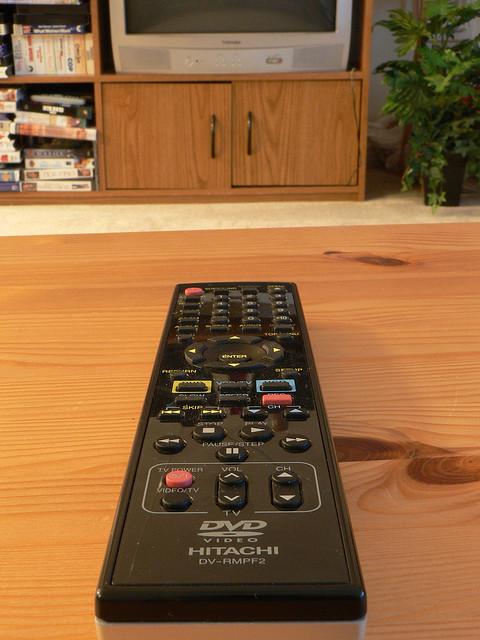What is this remote used for?
Write a very short answer. Tv. What electronic device can be seen?
Concise answer only. Tv. What is on top of the table?
Be succinct. Remote control. 